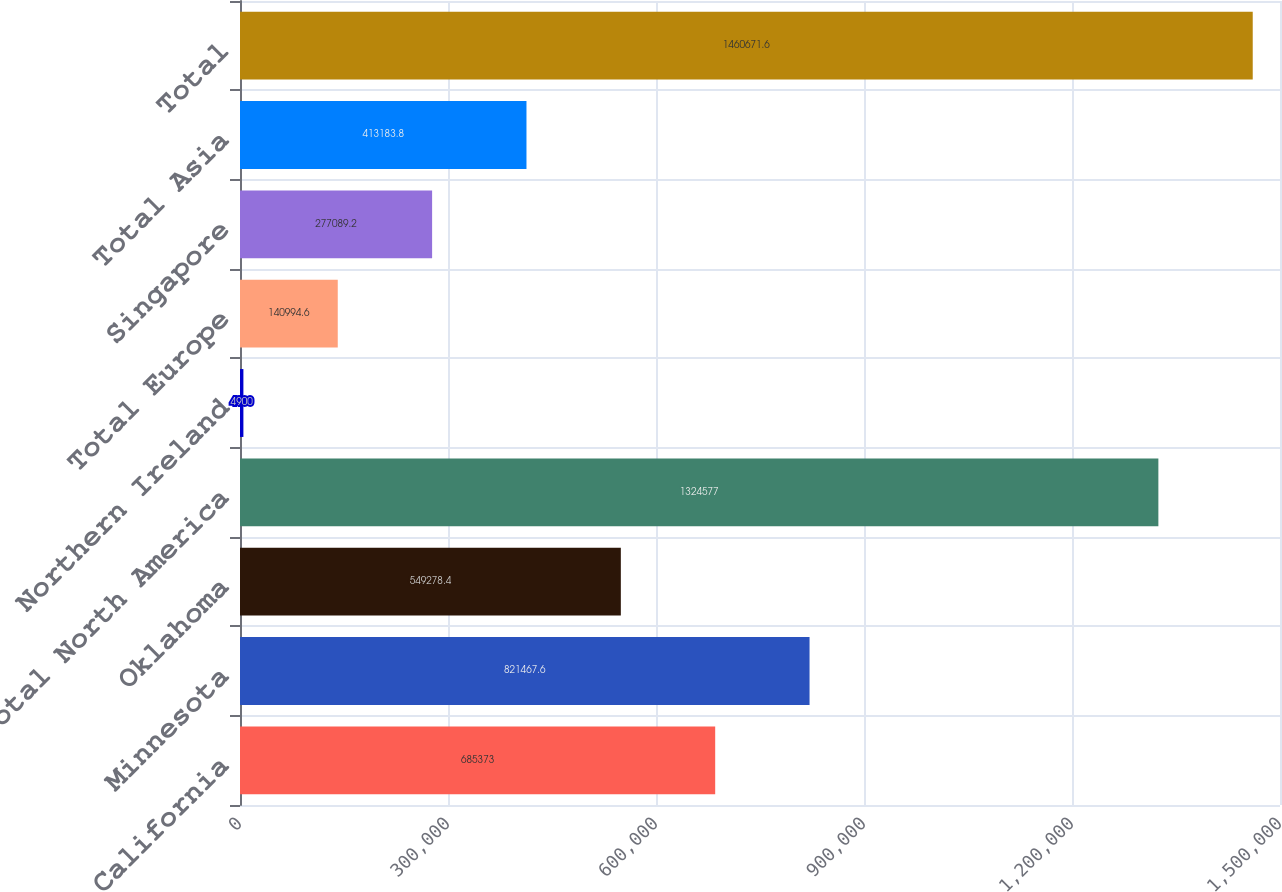Convert chart to OTSL. <chart><loc_0><loc_0><loc_500><loc_500><bar_chart><fcel>California<fcel>Minnesota<fcel>Oklahoma<fcel>Total North America<fcel>Northern Ireland<fcel>Total Europe<fcel>Singapore<fcel>Total Asia<fcel>Total<nl><fcel>685373<fcel>821468<fcel>549278<fcel>1.32458e+06<fcel>4900<fcel>140995<fcel>277089<fcel>413184<fcel>1.46067e+06<nl></chart> 